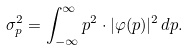<formula> <loc_0><loc_0><loc_500><loc_500>\sigma _ { p } ^ { 2 } = \int _ { - \infty } ^ { \infty } p ^ { 2 } \cdot | \varphi ( p ) | ^ { 2 } \, d p .</formula> 